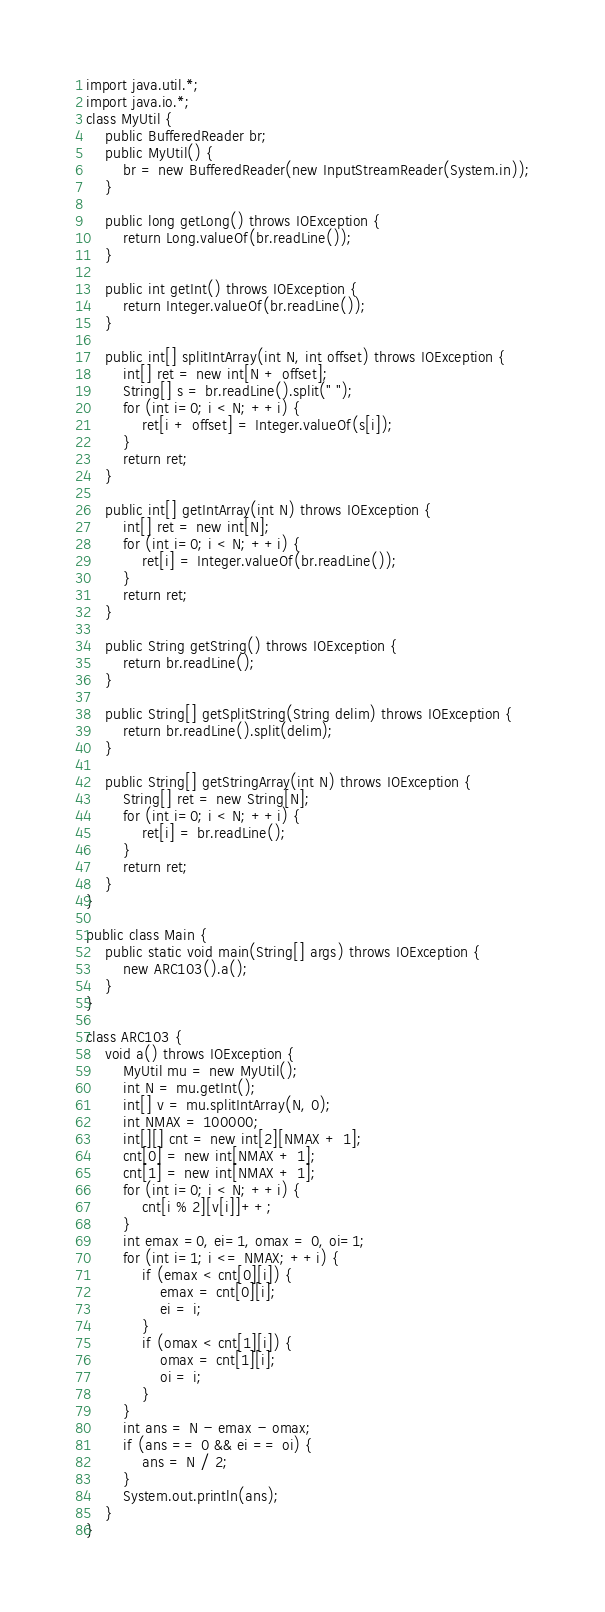<code> <loc_0><loc_0><loc_500><loc_500><_Java_>import java.util.*;
import java.io.*;
class MyUtil {
	public BufferedReader br;
	public MyUtil() {
		br = new BufferedReader(new InputStreamReader(System.in));
	}

	public long getLong() throws IOException {
		return Long.valueOf(br.readLine());
	}

	public int getInt() throws IOException {
		return Integer.valueOf(br.readLine());
	}

	public int[] splitIntArray(int N, int offset) throws IOException {
		int[] ret = new int[N + offset];
		String[] s = br.readLine().split(" ");
		for (int i=0; i < N; ++i) {
			ret[i + offset] = Integer.valueOf(s[i]);
		}
		return ret;
	}

	public int[] getIntArray(int N) throws IOException {
		int[] ret = new int[N];
		for (int i=0; i < N; ++i) {
			ret[i] = Integer.valueOf(br.readLine());
		}
		return ret;
	}

	public String getString() throws IOException {
		return br.readLine();
	}

	public String[] getSplitString(String delim) throws IOException {
		return br.readLine().split(delim);
	}

	public String[] getStringArray(int N) throws IOException {
		String[] ret = new String[N];
		for (int i=0; i < N; ++i) {
			ret[i] = br.readLine();
		}
		return ret;
	}
}

public class Main {
	public static void main(String[] args) throws IOException {
		new ARC103().a();
	}
}

class ARC103 {
	void a() throws IOException {
		MyUtil mu = new MyUtil();
		int N = mu.getInt();
		int[] v = mu.splitIntArray(N, 0);
		int NMAX = 100000;
		int[][] cnt = new int[2][NMAX + 1];
		cnt[0] = new int[NMAX + 1];
		cnt[1] = new int[NMAX + 1];
		for (int i=0; i < N; ++i) {
			cnt[i % 2][v[i]]++;
		}
		int emax =0, ei=1, omax = 0, oi=1;
		for (int i=1; i <= NMAX; ++i) {
			if (emax < cnt[0][i]) {
				emax = cnt[0][i];
				ei = i;
			}
			if (omax < cnt[1][i]) {
				omax = cnt[1][i];
				oi = i;
			}
		}		
		int ans = N - emax - omax;
		if (ans == 0 && ei == oi) {
			ans = N / 2;
		}
		System.out.println(ans);
	}
}</code> 